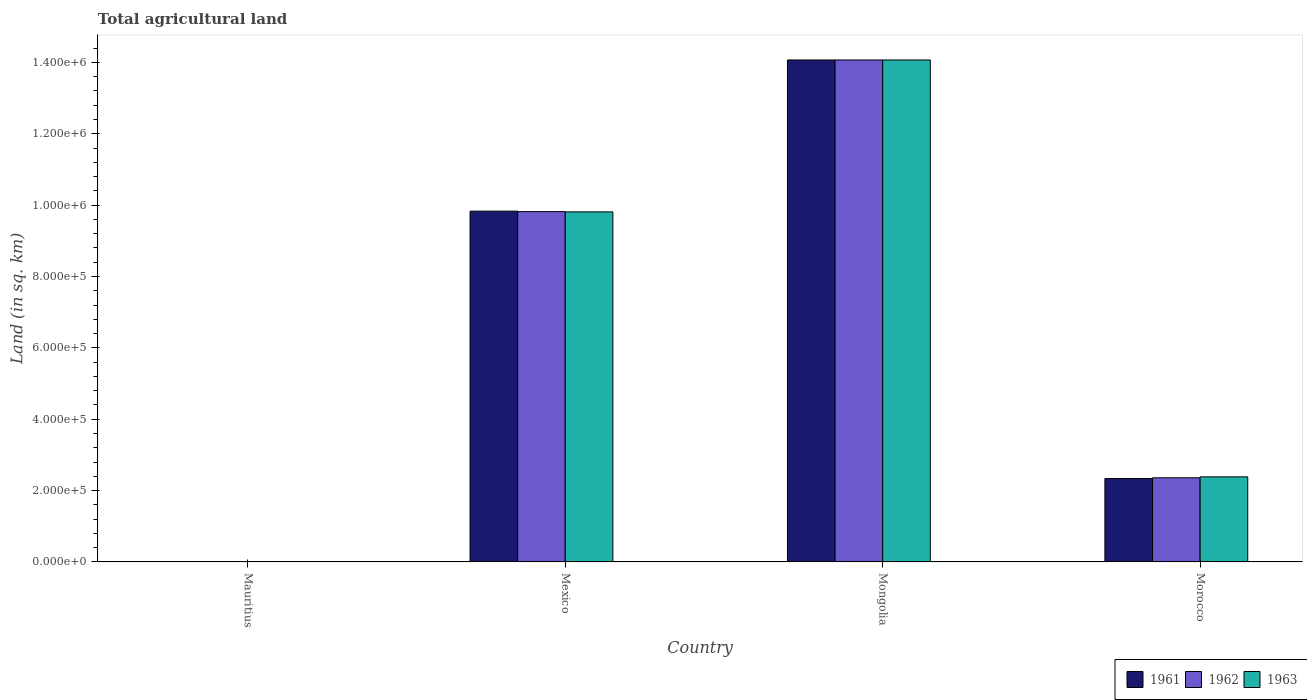How many bars are there on the 2nd tick from the left?
Make the answer very short. 3. How many bars are there on the 1st tick from the right?
Your response must be concise. 3. What is the label of the 1st group of bars from the left?
Provide a succinct answer. Mauritius. What is the total agricultural land in 1963 in Mexico?
Offer a very short reply. 9.81e+05. Across all countries, what is the maximum total agricultural land in 1963?
Offer a terse response. 1.41e+06. Across all countries, what is the minimum total agricultural land in 1961?
Ensure brevity in your answer.  990. In which country was the total agricultural land in 1963 maximum?
Ensure brevity in your answer.  Mongolia. In which country was the total agricultural land in 1963 minimum?
Your response must be concise. Mauritius. What is the total total agricultural land in 1962 in the graph?
Your answer should be very brief. 2.63e+06. What is the difference between the total agricultural land in 1963 in Mexico and that in Mongolia?
Keep it short and to the point. -4.26e+05. What is the difference between the total agricultural land in 1961 in Mauritius and the total agricultural land in 1962 in Mongolia?
Offer a terse response. -1.41e+06. What is the average total agricultural land in 1962 per country?
Make the answer very short. 6.56e+05. What is the ratio of the total agricultural land in 1961 in Mexico to that in Morocco?
Offer a very short reply. 4.21. Is the difference between the total agricultural land in 1963 in Mexico and Morocco greater than the difference between the total agricultural land in 1962 in Mexico and Morocco?
Keep it short and to the point. No. What is the difference between the highest and the second highest total agricultural land in 1961?
Offer a terse response. 7.49e+05. What is the difference between the highest and the lowest total agricultural land in 1962?
Your response must be concise. 1.41e+06. What does the 2nd bar from the right in Mexico represents?
Ensure brevity in your answer.  1962. Is it the case that in every country, the sum of the total agricultural land in 1961 and total agricultural land in 1962 is greater than the total agricultural land in 1963?
Offer a very short reply. Yes. Are all the bars in the graph horizontal?
Ensure brevity in your answer.  No. Does the graph contain grids?
Your answer should be compact. No. Where does the legend appear in the graph?
Your answer should be compact. Bottom right. How many legend labels are there?
Keep it short and to the point. 3. How are the legend labels stacked?
Provide a short and direct response. Horizontal. What is the title of the graph?
Your answer should be compact. Total agricultural land. What is the label or title of the Y-axis?
Offer a terse response. Land (in sq. km). What is the Land (in sq. km) in 1961 in Mauritius?
Your answer should be compact. 990. What is the Land (in sq. km) of 1963 in Mauritius?
Offer a terse response. 1000. What is the Land (in sq. km) of 1961 in Mexico?
Your answer should be compact. 9.83e+05. What is the Land (in sq. km) in 1962 in Mexico?
Make the answer very short. 9.82e+05. What is the Land (in sq. km) in 1963 in Mexico?
Provide a short and direct response. 9.81e+05. What is the Land (in sq. km) in 1961 in Mongolia?
Keep it short and to the point. 1.41e+06. What is the Land (in sq. km) of 1962 in Mongolia?
Your response must be concise. 1.41e+06. What is the Land (in sq. km) of 1963 in Mongolia?
Your answer should be compact. 1.41e+06. What is the Land (in sq. km) of 1961 in Morocco?
Keep it short and to the point. 2.34e+05. What is the Land (in sq. km) of 1962 in Morocco?
Provide a short and direct response. 2.36e+05. What is the Land (in sq. km) in 1963 in Morocco?
Offer a terse response. 2.38e+05. Across all countries, what is the maximum Land (in sq. km) of 1961?
Your answer should be compact. 1.41e+06. Across all countries, what is the maximum Land (in sq. km) of 1962?
Provide a succinct answer. 1.41e+06. Across all countries, what is the maximum Land (in sq. km) in 1963?
Provide a succinct answer. 1.41e+06. Across all countries, what is the minimum Land (in sq. km) of 1961?
Offer a very short reply. 990. Across all countries, what is the minimum Land (in sq. km) of 1963?
Your response must be concise. 1000. What is the total Land (in sq. km) of 1961 in the graph?
Provide a succinct answer. 2.62e+06. What is the total Land (in sq. km) of 1962 in the graph?
Offer a very short reply. 2.63e+06. What is the total Land (in sq. km) of 1963 in the graph?
Provide a succinct answer. 2.63e+06. What is the difference between the Land (in sq. km) of 1961 in Mauritius and that in Mexico?
Make the answer very short. -9.82e+05. What is the difference between the Land (in sq. km) of 1962 in Mauritius and that in Mexico?
Offer a very short reply. -9.81e+05. What is the difference between the Land (in sq. km) of 1963 in Mauritius and that in Mexico?
Offer a very short reply. -9.80e+05. What is the difference between the Land (in sq. km) of 1961 in Mauritius and that in Mongolia?
Give a very brief answer. -1.41e+06. What is the difference between the Land (in sq. km) in 1962 in Mauritius and that in Mongolia?
Offer a terse response. -1.41e+06. What is the difference between the Land (in sq. km) in 1963 in Mauritius and that in Mongolia?
Offer a very short reply. -1.41e+06. What is the difference between the Land (in sq. km) in 1961 in Mauritius and that in Morocco?
Provide a succinct answer. -2.33e+05. What is the difference between the Land (in sq. km) of 1962 in Mauritius and that in Morocco?
Provide a succinct answer. -2.35e+05. What is the difference between the Land (in sq. km) in 1963 in Mauritius and that in Morocco?
Keep it short and to the point. -2.38e+05. What is the difference between the Land (in sq. km) in 1961 in Mexico and that in Mongolia?
Offer a very short reply. -4.24e+05. What is the difference between the Land (in sq. km) in 1962 in Mexico and that in Mongolia?
Your response must be concise. -4.25e+05. What is the difference between the Land (in sq. km) of 1963 in Mexico and that in Mongolia?
Offer a terse response. -4.26e+05. What is the difference between the Land (in sq. km) in 1961 in Mexico and that in Morocco?
Your answer should be very brief. 7.49e+05. What is the difference between the Land (in sq. km) in 1962 in Mexico and that in Morocco?
Offer a very short reply. 7.46e+05. What is the difference between the Land (in sq. km) in 1963 in Mexico and that in Morocco?
Your response must be concise. 7.43e+05. What is the difference between the Land (in sq. km) of 1961 in Mongolia and that in Morocco?
Your answer should be compact. 1.17e+06. What is the difference between the Land (in sq. km) in 1962 in Mongolia and that in Morocco?
Give a very brief answer. 1.17e+06. What is the difference between the Land (in sq. km) in 1963 in Mongolia and that in Morocco?
Your answer should be compact. 1.17e+06. What is the difference between the Land (in sq. km) of 1961 in Mauritius and the Land (in sq. km) of 1962 in Mexico?
Give a very brief answer. -9.81e+05. What is the difference between the Land (in sq. km) of 1961 in Mauritius and the Land (in sq. km) of 1963 in Mexico?
Offer a very short reply. -9.80e+05. What is the difference between the Land (in sq. km) of 1962 in Mauritius and the Land (in sq. km) of 1963 in Mexico?
Keep it short and to the point. -9.80e+05. What is the difference between the Land (in sq. km) in 1961 in Mauritius and the Land (in sq. km) in 1962 in Mongolia?
Offer a very short reply. -1.41e+06. What is the difference between the Land (in sq. km) in 1961 in Mauritius and the Land (in sq. km) in 1963 in Mongolia?
Provide a short and direct response. -1.41e+06. What is the difference between the Land (in sq. km) of 1962 in Mauritius and the Land (in sq. km) of 1963 in Mongolia?
Keep it short and to the point. -1.41e+06. What is the difference between the Land (in sq. km) of 1961 in Mauritius and the Land (in sq. km) of 1962 in Morocco?
Your answer should be very brief. -2.35e+05. What is the difference between the Land (in sq. km) in 1961 in Mauritius and the Land (in sq. km) in 1963 in Morocco?
Make the answer very short. -2.38e+05. What is the difference between the Land (in sq. km) of 1962 in Mauritius and the Land (in sq. km) of 1963 in Morocco?
Your response must be concise. -2.38e+05. What is the difference between the Land (in sq. km) in 1961 in Mexico and the Land (in sq. km) in 1962 in Mongolia?
Ensure brevity in your answer.  -4.24e+05. What is the difference between the Land (in sq. km) in 1961 in Mexico and the Land (in sq. km) in 1963 in Mongolia?
Give a very brief answer. -4.24e+05. What is the difference between the Land (in sq. km) in 1962 in Mexico and the Land (in sq. km) in 1963 in Mongolia?
Your answer should be compact. -4.25e+05. What is the difference between the Land (in sq. km) in 1961 in Mexico and the Land (in sq. km) in 1962 in Morocco?
Give a very brief answer. 7.47e+05. What is the difference between the Land (in sq. km) of 1961 in Mexico and the Land (in sq. km) of 1963 in Morocco?
Make the answer very short. 7.45e+05. What is the difference between the Land (in sq. km) in 1962 in Mexico and the Land (in sq. km) in 1963 in Morocco?
Ensure brevity in your answer.  7.43e+05. What is the difference between the Land (in sq. km) of 1961 in Mongolia and the Land (in sq. km) of 1962 in Morocco?
Offer a very short reply. 1.17e+06. What is the difference between the Land (in sq. km) in 1961 in Mongolia and the Land (in sq. km) in 1963 in Morocco?
Your response must be concise. 1.17e+06. What is the difference between the Land (in sq. km) of 1962 in Mongolia and the Land (in sq. km) of 1963 in Morocco?
Provide a short and direct response. 1.17e+06. What is the average Land (in sq. km) in 1961 per country?
Ensure brevity in your answer.  6.56e+05. What is the average Land (in sq. km) of 1962 per country?
Offer a terse response. 6.56e+05. What is the average Land (in sq. km) of 1963 per country?
Keep it short and to the point. 6.57e+05. What is the difference between the Land (in sq. km) in 1961 and Land (in sq. km) in 1962 in Mexico?
Ensure brevity in your answer.  1370. What is the difference between the Land (in sq. km) of 1961 and Land (in sq. km) of 1963 in Mexico?
Your answer should be compact. 2070. What is the difference between the Land (in sq. km) of 1962 and Land (in sq. km) of 1963 in Mexico?
Your response must be concise. 700. What is the difference between the Land (in sq. km) of 1961 and Land (in sq. km) of 1962 in Mongolia?
Your answer should be very brief. 0. What is the difference between the Land (in sq. km) in 1961 and Land (in sq. km) in 1963 in Mongolia?
Give a very brief answer. 0. What is the difference between the Land (in sq. km) of 1961 and Land (in sq. km) of 1962 in Morocco?
Your response must be concise. -2100. What is the difference between the Land (in sq. km) of 1961 and Land (in sq. km) of 1963 in Morocco?
Provide a short and direct response. -4800. What is the difference between the Land (in sq. km) of 1962 and Land (in sq. km) of 1963 in Morocco?
Offer a very short reply. -2700. What is the ratio of the Land (in sq. km) in 1961 in Mauritius to that in Mexico?
Your response must be concise. 0. What is the ratio of the Land (in sq. km) in 1963 in Mauritius to that in Mexico?
Ensure brevity in your answer.  0. What is the ratio of the Land (in sq. km) of 1961 in Mauritius to that in Mongolia?
Offer a terse response. 0. What is the ratio of the Land (in sq. km) of 1962 in Mauritius to that in Mongolia?
Ensure brevity in your answer.  0. What is the ratio of the Land (in sq. km) in 1963 in Mauritius to that in Mongolia?
Make the answer very short. 0. What is the ratio of the Land (in sq. km) in 1961 in Mauritius to that in Morocco?
Provide a succinct answer. 0. What is the ratio of the Land (in sq. km) of 1962 in Mauritius to that in Morocco?
Provide a short and direct response. 0. What is the ratio of the Land (in sq. km) in 1963 in Mauritius to that in Morocco?
Ensure brevity in your answer.  0. What is the ratio of the Land (in sq. km) of 1961 in Mexico to that in Mongolia?
Keep it short and to the point. 0.7. What is the ratio of the Land (in sq. km) in 1962 in Mexico to that in Mongolia?
Provide a short and direct response. 0.7. What is the ratio of the Land (in sq. km) of 1963 in Mexico to that in Mongolia?
Provide a succinct answer. 0.7. What is the ratio of the Land (in sq. km) in 1961 in Mexico to that in Morocco?
Your answer should be very brief. 4.21. What is the ratio of the Land (in sq. km) of 1962 in Mexico to that in Morocco?
Make the answer very short. 4.16. What is the ratio of the Land (in sq. km) of 1963 in Mexico to that in Morocco?
Ensure brevity in your answer.  4.11. What is the ratio of the Land (in sq. km) in 1961 in Mongolia to that in Morocco?
Your response must be concise. 6.02. What is the ratio of the Land (in sq. km) of 1962 in Mongolia to that in Morocco?
Ensure brevity in your answer.  5.97. What is the ratio of the Land (in sq. km) of 1963 in Mongolia to that in Morocco?
Ensure brevity in your answer.  5.9. What is the difference between the highest and the second highest Land (in sq. km) of 1961?
Keep it short and to the point. 4.24e+05. What is the difference between the highest and the second highest Land (in sq. km) in 1962?
Your answer should be compact. 4.25e+05. What is the difference between the highest and the second highest Land (in sq. km) in 1963?
Provide a short and direct response. 4.26e+05. What is the difference between the highest and the lowest Land (in sq. km) of 1961?
Your response must be concise. 1.41e+06. What is the difference between the highest and the lowest Land (in sq. km) in 1962?
Your answer should be very brief. 1.41e+06. What is the difference between the highest and the lowest Land (in sq. km) of 1963?
Offer a very short reply. 1.41e+06. 